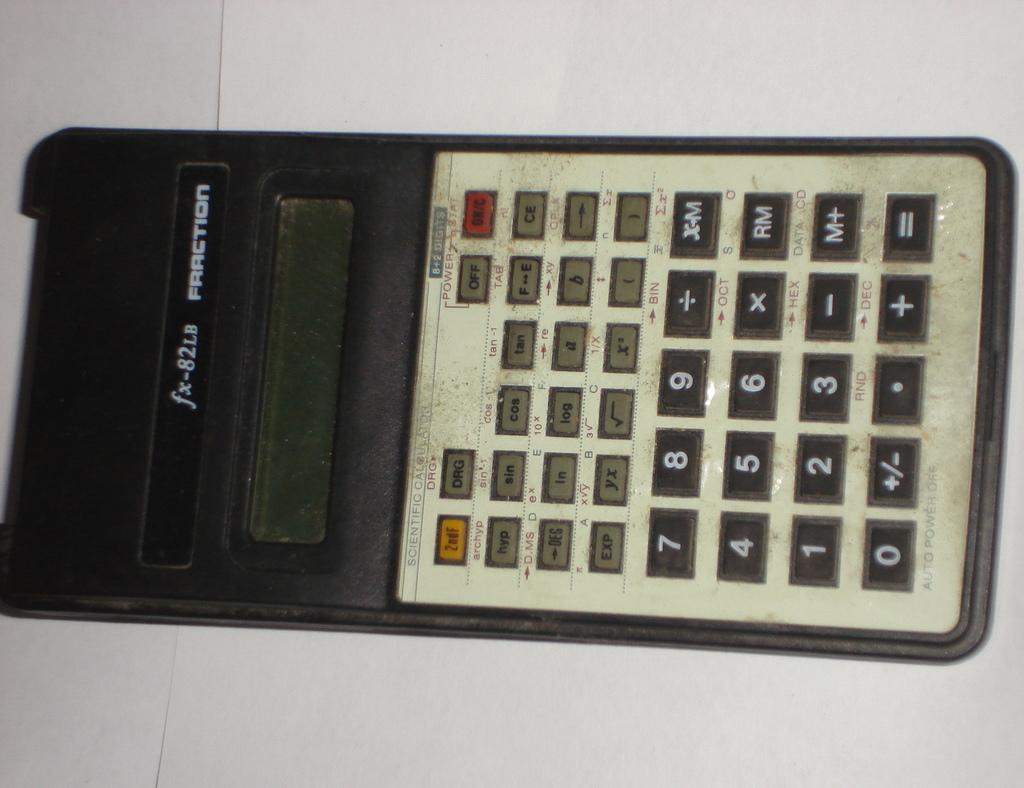<image>
Give a short and clear explanation of the subsequent image. fx-82LB Fraction is the brand shown on this calculator. 